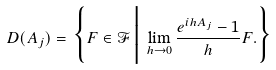<formula> <loc_0><loc_0><loc_500><loc_500>D ( A _ { j } ) = \Big \{ F \in \mathcal { F } \, \Big | \, \lim _ { h \to 0 } \frac { e ^ { i h A _ { j } } - 1 } { h } F . \Big \}</formula> 